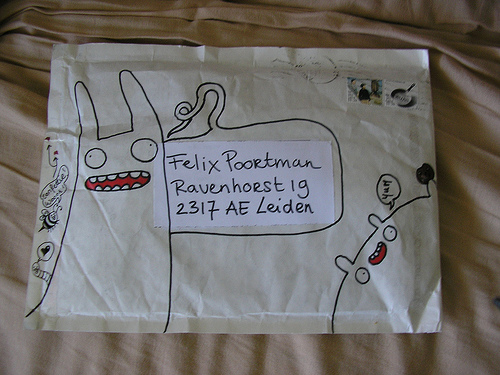<image>
Is there a paper under the envelope? No. The paper is not positioned under the envelope. The vertical relationship between these objects is different. Is there a drawing on the cloth? No. The drawing is not positioned on the cloth. They may be near each other, but the drawing is not supported by or resting on top of the cloth. 